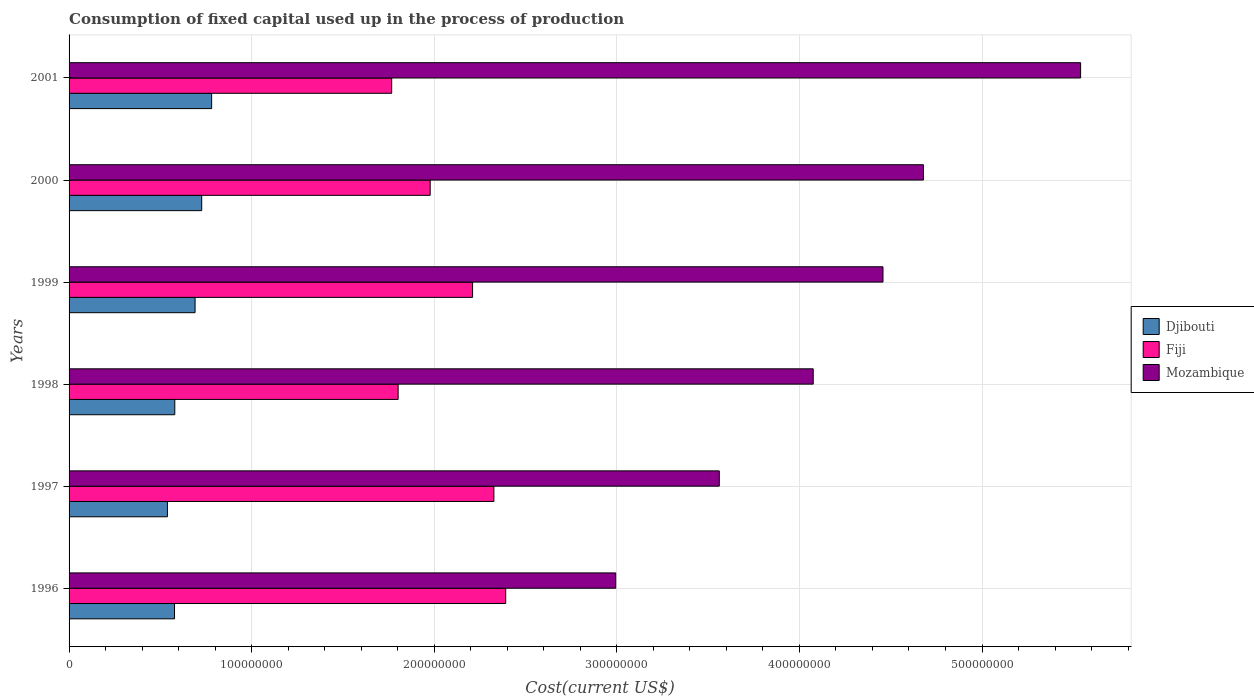How many groups of bars are there?
Make the answer very short. 6. Are the number of bars per tick equal to the number of legend labels?
Give a very brief answer. Yes. Are the number of bars on each tick of the Y-axis equal?
Keep it short and to the point. Yes. How many bars are there on the 4th tick from the top?
Offer a very short reply. 3. How many bars are there on the 6th tick from the bottom?
Ensure brevity in your answer.  3. What is the label of the 4th group of bars from the top?
Offer a very short reply. 1998. What is the amount consumed in the process of production in Mozambique in 2000?
Your response must be concise. 4.68e+08. Across all years, what is the maximum amount consumed in the process of production in Mozambique?
Offer a terse response. 5.54e+08. Across all years, what is the minimum amount consumed in the process of production in Djibouti?
Give a very brief answer. 5.39e+07. In which year was the amount consumed in the process of production in Djibouti minimum?
Offer a terse response. 1997. What is the total amount consumed in the process of production in Fiji in the graph?
Provide a short and direct response. 1.25e+09. What is the difference between the amount consumed in the process of production in Fiji in 1999 and that in 2001?
Ensure brevity in your answer.  4.43e+07. What is the difference between the amount consumed in the process of production in Fiji in 2000 and the amount consumed in the process of production in Mozambique in 2001?
Provide a succinct answer. -3.56e+08. What is the average amount consumed in the process of production in Fiji per year?
Your answer should be very brief. 2.08e+08. In the year 1996, what is the difference between the amount consumed in the process of production in Djibouti and amount consumed in the process of production in Mozambique?
Give a very brief answer. -2.42e+08. What is the ratio of the amount consumed in the process of production in Djibouti in 1996 to that in 2001?
Ensure brevity in your answer.  0.74. Is the amount consumed in the process of production in Djibouti in 1996 less than that in 1999?
Offer a very short reply. Yes. What is the difference between the highest and the second highest amount consumed in the process of production in Fiji?
Your response must be concise. 6.47e+06. What is the difference between the highest and the lowest amount consumed in the process of production in Mozambique?
Provide a short and direct response. 2.55e+08. What does the 1st bar from the top in 1999 represents?
Provide a short and direct response. Mozambique. What does the 1st bar from the bottom in 1998 represents?
Offer a very short reply. Djibouti. How many bars are there?
Offer a terse response. 18. Are all the bars in the graph horizontal?
Provide a short and direct response. Yes. What is the difference between two consecutive major ticks on the X-axis?
Offer a very short reply. 1.00e+08. Are the values on the major ticks of X-axis written in scientific E-notation?
Ensure brevity in your answer.  No. Does the graph contain grids?
Make the answer very short. Yes. How are the legend labels stacked?
Your answer should be compact. Vertical. What is the title of the graph?
Your answer should be very brief. Consumption of fixed capital used up in the process of production. Does "Luxembourg" appear as one of the legend labels in the graph?
Offer a very short reply. No. What is the label or title of the X-axis?
Provide a succinct answer. Cost(current US$). What is the label or title of the Y-axis?
Keep it short and to the point. Years. What is the Cost(current US$) of Djibouti in 1996?
Make the answer very short. 5.78e+07. What is the Cost(current US$) of Fiji in 1996?
Keep it short and to the point. 2.39e+08. What is the Cost(current US$) in Mozambique in 1996?
Your response must be concise. 2.99e+08. What is the Cost(current US$) in Djibouti in 1997?
Provide a short and direct response. 5.39e+07. What is the Cost(current US$) in Fiji in 1997?
Give a very brief answer. 2.33e+08. What is the Cost(current US$) in Mozambique in 1997?
Your answer should be compact. 3.56e+08. What is the Cost(current US$) in Djibouti in 1998?
Your answer should be very brief. 5.79e+07. What is the Cost(current US$) of Fiji in 1998?
Your answer should be very brief. 1.80e+08. What is the Cost(current US$) of Mozambique in 1998?
Provide a succinct answer. 4.08e+08. What is the Cost(current US$) in Djibouti in 1999?
Your answer should be compact. 6.90e+07. What is the Cost(current US$) of Fiji in 1999?
Provide a succinct answer. 2.21e+08. What is the Cost(current US$) of Mozambique in 1999?
Provide a succinct answer. 4.46e+08. What is the Cost(current US$) of Djibouti in 2000?
Keep it short and to the point. 7.26e+07. What is the Cost(current US$) in Fiji in 2000?
Provide a succinct answer. 1.98e+08. What is the Cost(current US$) in Mozambique in 2000?
Keep it short and to the point. 4.68e+08. What is the Cost(current US$) of Djibouti in 2001?
Offer a terse response. 7.81e+07. What is the Cost(current US$) in Fiji in 2001?
Provide a short and direct response. 1.77e+08. What is the Cost(current US$) of Mozambique in 2001?
Your response must be concise. 5.54e+08. Across all years, what is the maximum Cost(current US$) in Djibouti?
Provide a short and direct response. 7.81e+07. Across all years, what is the maximum Cost(current US$) of Fiji?
Ensure brevity in your answer.  2.39e+08. Across all years, what is the maximum Cost(current US$) of Mozambique?
Offer a terse response. 5.54e+08. Across all years, what is the minimum Cost(current US$) of Djibouti?
Make the answer very short. 5.39e+07. Across all years, what is the minimum Cost(current US$) of Fiji?
Your answer should be very brief. 1.77e+08. Across all years, what is the minimum Cost(current US$) of Mozambique?
Ensure brevity in your answer.  2.99e+08. What is the total Cost(current US$) in Djibouti in the graph?
Give a very brief answer. 3.89e+08. What is the total Cost(current US$) in Fiji in the graph?
Provide a succinct answer. 1.25e+09. What is the total Cost(current US$) of Mozambique in the graph?
Ensure brevity in your answer.  2.53e+09. What is the difference between the Cost(current US$) of Djibouti in 1996 and that in 1997?
Your response must be concise. 3.88e+06. What is the difference between the Cost(current US$) of Fiji in 1996 and that in 1997?
Provide a succinct answer. 6.47e+06. What is the difference between the Cost(current US$) of Mozambique in 1996 and that in 1997?
Your answer should be compact. -5.67e+07. What is the difference between the Cost(current US$) in Djibouti in 1996 and that in 1998?
Provide a succinct answer. -1.52e+05. What is the difference between the Cost(current US$) in Fiji in 1996 and that in 1998?
Ensure brevity in your answer.  5.89e+07. What is the difference between the Cost(current US$) of Mozambique in 1996 and that in 1998?
Offer a very short reply. -1.08e+08. What is the difference between the Cost(current US$) of Djibouti in 1996 and that in 1999?
Keep it short and to the point. -1.13e+07. What is the difference between the Cost(current US$) of Fiji in 1996 and that in 1999?
Your answer should be compact. 1.81e+07. What is the difference between the Cost(current US$) of Mozambique in 1996 and that in 1999?
Offer a very short reply. -1.46e+08. What is the difference between the Cost(current US$) in Djibouti in 1996 and that in 2000?
Offer a terse response. -1.49e+07. What is the difference between the Cost(current US$) of Fiji in 1996 and that in 2000?
Your response must be concise. 4.14e+07. What is the difference between the Cost(current US$) in Mozambique in 1996 and that in 2000?
Give a very brief answer. -1.69e+08. What is the difference between the Cost(current US$) of Djibouti in 1996 and that in 2001?
Offer a terse response. -2.03e+07. What is the difference between the Cost(current US$) of Fiji in 1996 and that in 2001?
Your answer should be very brief. 6.24e+07. What is the difference between the Cost(current US$) of Mozambique in 1996 and that in 2001?
Your answer should be very brief. -2.55e+08. What is the difference between the Cost(current US$) in Djibouti in 1997 and that in 1998?
Give a very brief answer. -4.03e+06. What is the difference between the Cost(current US$) of Fiji in 1997 and that in 1998?
Your answer should be very brief. 5.24e+07. What is the difference between the Cost(current US$) of Mozambique in 1997 and that in 1998?
Make the answer very short. -5.14e+07. What is the difference between the Cost(current US$) of Djibouti in 1997 and that in 1999?
Your answer should be compact. -1.51e+07. What is the difference between the Cost(current US$) of Fiji in 1997 and that in 1999?
Your response must be concise. 1.17e+07. What is the difference between the Cost(current US$) in Mozambique in 1997 and that in 1999?
Provide a succinct answer. -8.96e+07. What is the difference between the Cost(current US$) in Djibouti in 1997 and that in 2000?
Offer a terse response. -1.88e+07. What is the difference between the Cost(current US$) in Fiji in 1997 and that in 2000?
Offer a very short reply. 3.49e+07. What is the difference between the Cost(current US$) of Mozambique in 1997 and that in 2000?
Provide a succinct answer. -1.12e+08. What is the difference between the Cost(current US$) in Djibouti in 1997 and that in 2001?
Offer a very short reply. -2.42e+07. What is the difference between the Cost(current US$) in Fiji in 1997 and that in 2001?
Provide a succinct answer. 5.60e+07. What is the difference between the Cost(current US$) of Mozambique in 1997 and that in 2001?
Your answer should be compact. -1.98e+08. What is the difference between the Cost(current US$) of Djibouti in 1998 and that in 1999?
Provide a succinct answer. -1.11e+07. What is the difference between the Cost(current US$) of Fiji in 1998 and that in 1999?
Give a very brief answer. -4.08e+07. What is the difference between the Cost(current US$) of Mozambique in 1998 and that in 1999?
Your response must be concise. -3.82e+07. What is the difference between the Cost(current US$) in Djibouti in 1998 and that in 2000?
Ensure brevity in your answer.  -1.47e+07. What is the difference between the Cost(current US$) of Fiji in 1998 and that in 2000?
Keep it short and to the point. -1.75e+07. What is the difference between the Cost(current US$) of Mozambique in 1998 and that in 2000?
Your answer should be very brief. -6.04e+07. What is the difference between the Cost(current US$) in Djibouti in 1998 and that in 2001?
Your answer should be compact. -2.02e+07. What is the difference between the Cost(current US$) of Fiji in 1998 and that in 2001?
Ensure brevity in your answer.  3.54e+06. What is the difference between the Cost(current US$) of Mozambique in 1998 and that in 2001?
Offer a terse response. -1.46e+08. What is the difference between the Cost(current US$) of Djibouti in 1999 and that in 2000?
Make the answer very short. -3.63e+06. What is the difference between the Cost(current US$) in Fiji in 1999 and that in 2000?
Offer a very short reply. 2.32e+07. What is the difference between the Cost(current US$) in Mozambique in 1999 and that in 2000?
Offer a very short reply. -2.21e+07. What is the difference between the Cost(current US$) of Djibouti in 1999 and that in 2001?
Your response must be concise. -9.07e+06. What is the difference between the Cost(current US$) in Fiji in 1999 and that in 2001?
Your answer should be very brief. 4.43e+07. What is the difference between the Cost(current US$) of Mozambique in 1999 and that in 2001?
Make the answer very short. -1.08e+08. What is the difference between the Cost(current US$) in Djibouti in 2000 and that in 2001?
Provide a short and direct response. -5.44e+06. What is the difference between the Cost(current US$) in Fiji in 2000 and that in 2001?
Provide a short and direct response. 2.11e+07. What is the difference between the Cost(current US$) in Mozambique in 2000 and that in 2001?
Keep it short and to the point. -8.61e+07. What is the difference between the Cost(current US$) of Djibouti in 1996 and the Cost(current US$) of Fiji in 1997?
Offer a terse response. -1.75e+08. What is the difference between the Cost(current US$) in Djibouti in 1996 and the Cost(current US$) in Mozambique in 1997?
Your response must be concise. -2.98e+08. What is the difference between the Cost(current US$) of Fiji in 1996 and the Cost(current US$) of Mozambique in 1997?
Ensure brevity in your answer.  -1.17e+08. What is the difference between the Cost(current US$) in Djibouti in 1996 and the Cost(current US$) in Fiji in 1998?
Offer a terse response. -1.22e+08. What is the difference between the Cost(current US$) of Djibouti in 1996 and the Cost(current US$) of Mozambique in 1998?
Your response must be concise. -3.50e+08. What is the difference between the Cost(current US$) in Fiji in 1996 and the Cost(current US$) in Mozambique in 1998?
Offer a very short reply. -1.68e+08. What is the difference between the Cost(current US$) of Djibouti in 1996 and the Cost(current US$) of Fiji in 1999?
Offer a terse response. -1.63e+08. What is the difference between the Cost(current US$) of Djibouti in 1996 and the Cost(current US$) of Mozambique in 1999?
Your answer should be very brief. -3.88e+08. What is the difference between the Cost(current US$) of Fiji in 1996 and the Cost(current US$) of Mozambique in 1999?
Keep it short and to the point. -2.07e+08. What is the difference between the Cost(current US$) of Djibouti in 1996 and the Cost(current US$) of Fiji in 2000?
Your response must be concise. -1.40e+08. What is the difference between the Cost(current US$) in Djibouti in 1996 and the Cost(current US$) in Mozambique in 2000?
Offer a terse response. -4.10e+08. What is the difference between the Cost(current US$) of Fiji in 1996 and the Cost(current US$) of Mozambique in 2000?
Offer a terse response. -2.29e+08. What is the difference between the Cost(current US$) in Djibouti in 1996 and the Cost(current US$) in Fiji in 2001?
Your answer should be compact. -1.19e+08. What is the difference between the Cost(current US$) of Djibouti in 1996 and the Cost(current US$) of Mozambique in 2001?
Ensure brevity in your answer.  -4.96e+08. What is the difference between the Cost(current US$) in Fiji in 1996 and the Cost(current US$) in Mozambique in 2001?
Your response must be concise. -3.15e+08. What is the difference between the Cost(current US$) in Djibouti in 1997 and the Cost(current US$) in Fiji in 1998?
Your answer should be compact. -1.26e+08. What is the difference between the Cost(current US$) in Djibouti in 1997 and the Cost(current US$) in Mozambique in 1998?
Your answer should be compact. -3.54e+08. What is the difference between the Cost(current US$) of Fiji in 1997 and the Cost(current US$) of Mozambique in 1998?
Make the answer very short. -1.75e+08. What is the difference between the Cost(current US$) in Djibouti in 1997 and the Cost(current US$) in Fiji in 1999?
Offer a very short reply. -1.67e+08. What is the difference between the Cost(current US$) of Djibouti in 1997 and the Cost(current US$) of Mozambique in 1999?
Offer a terse response. -3.92e+08. What is the difference between the Cost(current US$) of Fiji in 1997 and the Cost(current US$) of Mozambique in 1999?
Ensure brevity in your answer.  -2.13e+08. What is the difference between the Cost(current US$) in Djibouti in 1997 and the Cost(current US$) in Fiji in 2000?
Ensure brevity in your answer.  -1.44e+08. What is the difference between the Cost(current US$) in Djibouti in 1997 and the Cost(current US$) in Mozambique in 2000?
Keep it short and to the point. -4.14e+08. What is the difference between the Cost(current US$) of Fiji in 1997 and the Cost(current US$) of Mozambique in 2000?
Make the answer very short. -2.35e+08. What is the difference between the Cost(current US$) of Djibouti in 1997 and the Cost(current US$) of Fiji in 2001?
Offer a very short reply. -1.23e+08. What is the difference between the Cost(current US$) of Djibouti in 1997 and the Cost(current US$) of Mozambique in 2001?
Offer a terse response. -5.00e+08. What is the difference between the Cost(current US$) of Fiji in 1997 and the Cost(current US$) of Mozambique in 2001?
Your answer should be very brief. -3.21e+08. What is the difference between the Cost(current US$) of Djibouti in 1998 and the Cost(current US$) of Fiji in 1999?
Offer a terse response. -1.63e+08. What is the difference between the Cost(current US$) in Djibouti in 1998 and the Cost(current US$) in Mozambique in 1999?
Your answer should be compact. -3.88e+08. What is the difference between the Cost(current US$) of Fiji in 1998 and the Cost(current US$) of Mozambique in 1999?
Make the answer very short. -2.66e+08. What is the difference between the Cost(current US$) in Djibouti in 1998 and the Cost(current US$) in Fiji in 2000?
Provide a succinct answer. -1.40e+08. What is the difference between the Cost(current US$) in Djibouti in 1998 and the Cost(current US$) in Mozambique in 2000?
Your response must be concise. -4.10e+08. What is the difference between the Cost(current US$) of Fiji in 1998 and the Cost(current US$) of Mozambique in 2000?
Keep it short and to the point. -2.88e+08. What is the difference between the Cost(current US$) of Djibouti in 1998 and the Cost(current US$) of Fiji in 2001?
Provide a short and direct response. -1.19e+08. What is the difference between the Cost(current US$) in Djibouti in 1998 and the Cost(current US$) in Mozambique in 2001?
Your response must be concise. -4.96e+08. What is the difference between the Cost(current US$) of Fiji in 1998 and the Cost(current US$) of Mozambique in 2001?
Offer a terse response. -3.74e+08. What is the difference between the Cost(current US$) in Djibouti in 1999 and the Cost(current US$) in Fiji in 2000?
Make the answer very short. -1.29e+08. What is the difference between the Cost(current US$) in Djibouti in 1999 and the Cost(current US$) in Mozambique in 2000?
Your answer should be compact. -3.99e+08. What is the difference between the Cost(current US$) in Fiji in 1999 and the Cost(current US$) in Mozambique in 2000?
Offer a terse response. -2.47e+08. What is the difference between the Cost(current US$) of Djibouti in 1999 and the Cost(current US$) of Fiji in 2001?
Your answer should be compact. -1.08e+08. What is the difference between the Cost(current US$) of Djibouti in 1999 and the Cost(current US$) of Mozambique in 2001?
Make the answer very short. -4.85e+08. What is the difference between the Cost(current US$) in Fiji in 1999 and the Cost(current US$) in Mozambique in 2001?
Your answer should be very brief. -3.33e+08. What is the difference between the Cost(current US$) of Djibouti in 2000 and the Cost(current US$) of Fiji in 2001?
Give a very brief answer. -1.04e+08. What is the difference between the Cost(current US$) of Djibouti in 2000 and the Cost(current US$) of Mozambique in 2001?
Your response must be concise. -4.81e+08. What is the difference between the Cost(current US$) of Fiji in 2000 and the Cost(current US$) of Mozambique in 2001?
Offer a terse response. -3.56e+08. What is the average Cost(current US$) in Djibouti per year?
Make the answer very short. 6.49e+07. What is the average Cost(current US$) of Fiji per year?
Keep it short and to the point. 2.08e+08. What is the average Cost(current US$) of Mozambique per year?
Make the answer very short. 4.22e+08. In the year 1996, what is the difference between the Cost(current US$) in Djibouti and Cost(current US$) in Fiji?
Offer a very short reply. -1.81e+08. In the year 1996, what is the difference between the Cost(current US$) in Djibouti and Cost(current US$) in Mozambique?
Your response must be concise. -2.42e+08. In the year 1996, what is the difference between the Cost(current US$) in Fiji and Cost(current US$) in Mozambique?
Offer a terse response. -6.03e+07. In the year 1997, what is the difference between the Cost(current US$) of Djibouti and Cost(current US$) of Fiji?
Give a very brief answer. -1.79e+08. In the year 1997, what is the difference between the Cost(current US$) of Djibouti and Cost(current US$) of Mozambique?
Give a very brief answer. -3.02e+08. In the year 1997, what is the difference between the Cost(current US$) of Fiji and Cost(current US$) of Mozambique?
Your response must be concise. -1.23e+08. In the year 1998, what is the difference between the Cost(current US$) of Djibouti and Cost(current US$) of Fiji?
Your answer should be compact. -1.22e+08. In the year 1998, what is the difference between the Cost(current US$) of Djibouti and Cost(current US$) of Mozambique?
Your response must be concise. -3.50e+08. In the year 1998, what is the difference between the Cost(current US$) in Fiji and Cost(current US$) in Mozambique?
Offer a very short reply. -2.27e+08. In the year 1999, what is the difference between the Cost(current US$) of Djibouti and Cost(current US$) of Fiji?
Your answer should be very brief. -1.52e+08. In the year 1999, what is the difference between the Cost(current US$) of Djibouti and Cost(current US$) of Mozambique?
Offer a very short reply. -3.77e+08. In the year 1999, what is the difference between the Cost(current US$) in Fiji and Cost(current US$) in Mozambique?
Make the answer very short. -2.25e+08. In the year 2000, what is the difference between the Cost(current US$) in Djibouti and Cost(current US$) in Fiji?
Provide a succinct answer. -1.25e+08. In the year 2000, what is the difference between the Cost(current US$) of Djibouti and Cost(current US$) of Mozambique?
Your response must be concise. -3.95e+08. In the year 2000, what is the difference between the Cost(current US$) of Fiji and Cost(current US$) of Mozambique?
Offer a very short reply. -2.70e+08. In the year 2001, what is the difference between the Cost(current US$) of Djibouti and Cost(current US$) of Fiji?
Make the answer very short. -9.86e+07. In the year 2001, what is the difference between the Cost(current US$) in Djibouti and Cost(current US$) in Mozambique?
Keep it short and to the point. -4.76e+08. In the year 2001, what is the difference between the Cost(current US$) of Fiji and Cost(current US$) of Mozambique?
Offer a terse response. -3.77e+08. What is the ratio of the Cost(current US$) in Djibouti in 1996 to that in 1997?
Your answer should be compact. 1.07. What is the ratio of the Cost(current US$) in Fiji in 1996 to that in 1997?
Your answer should be compact. 1.03. What is the ratio of the Cost(current US$) of Mozambique in 1996 to that in 1997?
Provide a short and direct response. 0.84. What is the ratio of the Cost(current US$) of Fiji in 1996 to that in 1998?
Provide a short and direct response. 1.33. What is the ratio of the Cost(current US$) in Mozambique in 1996 to that in 1998?
Provide a short and direct response. 0.73. What is the ratio of the Cost(current US$) in Djibouti in 1996 to that in 1999?
Provide a short and direct response. 0.84. What is the ratio of the Cost(current US$) in Fiji in 1996 to that in 1999?
Ensure brevity in your answer.  1.08. What is the ratio of the Cost(current US$) of Mozambique in 1996 to that in 1999?
Provide a short and direct response. 0.67. What is the ratio of the Cost(current US$) in Djibouti in 1996 to that in 2000?
Keep it short and to the point. 0.8. What is the ratio of the Cost(current US$) of Fiji in 1996 to that in 2000?
Your answer should be compact. 1.21. What is the ratio of the Cost(current US$) in Mozambique in 1996 to that in 2000?
Ensure brevity in your answer.  0.64. What is the ratio of the Cost(current US$) in Djibouti in 1996 to that in 2001?
Keep it short and to the point. 0.74. What is the ratio of the Cost(current US$) in Fiji in 1996 to that in 2001?
Make the answer very short. 1.35. What is the ratio of the Cost(current US$) of Mozambique in 1996 to that in 2001?
Give a very brief answer. 0.54. What is the ratio of the Cost(current US$) of Djibouti in 1997 to that in 1998?
Give a very brief answer. 0.93. What is the ratio of the Cost(current US$) in Fiji in 1997 to that in 1998?
Your response must be concise. 1.29. What is the ratio of the Cost(current US$) of Mozambique in 1997 to that in 1998?
Your response must be concise. 0.87. What is the ratio of the Cost(current US$) in Djibouti in 1997 to that in 1999?
Provide a short and direct response. 0.78. What is the ratio of the Cost(current US$) in Fiji in 1997 to that in 1999?
Offer a terse response. 1.05. What is the ratio of the Cost(current US$) of Mozambique in 1997 to that in 1999?
Provide a succinct answer. 0.8. What is the ratio of the Cost(current US$) in Djibouti in 1997 to that in 2000?
Give a very brief answer. 0.74. What is the ratio of the Cost(current US$) of Fiji in 1997 to that in 2000?
Give a very brief answer. 1.18. What is the ratio of the Cost(current US$) in Mozambique in 1997 to that in 2000?
Your answer should be very brief. 0.76. What is the ratio of the Cost(current US$) of Djibouti in 1997 to that in 2001?
Give a very brief answer. 0.69. What is the ratio of the Cost(current US$) of Fiji in 1997 to that in 2001?
Provide a short and direct response. 1.32. What is the ratio of the Cost(current US$) in Mozambique in 1997 to that in 2001?
Your response must be concise. 0.64. What is the ratio of the Cost(current US$) in Djibouti in 1998 to that in 1999?
Keep it short and to the point. 0.84. What is the ratio of the Cost(current US$) of Fiji in 1998 to that in 1999?
Provide a short and direct response. 0.82. What is the ratio of the Cost(current US$) of Mozambique in 1998 to that in 1999?
Offer a terse response. 0.91. What is the ratio of the Cost(current US$) of Djibouti in 1998 to that in 2000?
Your answer should be very brief. 0.8. What is the ratio of the Cost(current US$) of Fiji in 1998 to that in 2000?
Your answer should be very brief. 0.91. What is the ratio of the Cost(current US$) of Mozambique in 1998 to that in 2000?
Provide a short and direct response. 0.87. What is the ratio of the Cost(current US$) in Djibouti in 1998 to that in 2001?
Your answer should be compact. 0.74. What is the ratio of the Cost(current US$) in Fiji in 1998 to that in 2001?
Your response must be concise. 1.02. What is the ratio of the Cost(current US$) of Mozambique in 1998 to that in 2001?
Ensure brevity in your answer.  0.74. What is the ratio of the Cost(current US$) in Djibouti in 1999 to that in 2000?
Make the answer very short. 0.95. What is the ratio of the Cost(current US$) in Fiji in 1999 to that in 2000?
Offer a terse response. 1.12. What is the ratio of the Cost(current US$) in Mozambique in 1999 to that in 2000?
Your answer should be very brief. 0.95. What is the ratio of the Cost(current US$) of Djibouti in 1999 to that in 2001?
Ensure brevity in your answer.  0.88. What is the ratio of the Cost(current US$) of Fiji in 1999 to that in 2001?
Your answer should be compact. 1.25. What is the ratio of the Cost(current US$) of Mozambique in 1999 to that in 2001?
Offer a terse response. 0.8. What is the ratio of the Cost(current US$) of Djibouti in 2000 to that in 2001?
Your answer should be very brief. 0.93. What is the ratio of the Cost(current US$) of Fiji in 2000 to that in 2001?
Your answer should be very brief. 1.12. What is the ratio of the Cost(current US$) in Mozambique in 2000 to that in 2001?
Offer a very short reply. 0.84. What is the difference between the highest and the second highest Cost(current US$) of Djibouti?
Give a very brief answer. 5.44e+06. What is the difference between the highest and the second highest Cost(current US$) in Fiji?
Ensure brevity in your answer.  6.47e+06. What is the difference between the highest and the second highest Cost(current US$) of Mozambique?
Provide a succinct answer. 8.61e+07. What is the difference between the highest and the lowest Cost(current US$) of Djibouti?
Offer a terse response. 2.42e+07. What is the difference between the highest and the lowest Cost(current US$) of Fiji?
Offer a very short reply. 6.24e+07. What is the difference between the highest and the lowest Cost(current US$) of Mozambique?
Make the answer very short. 2.55e+08. 